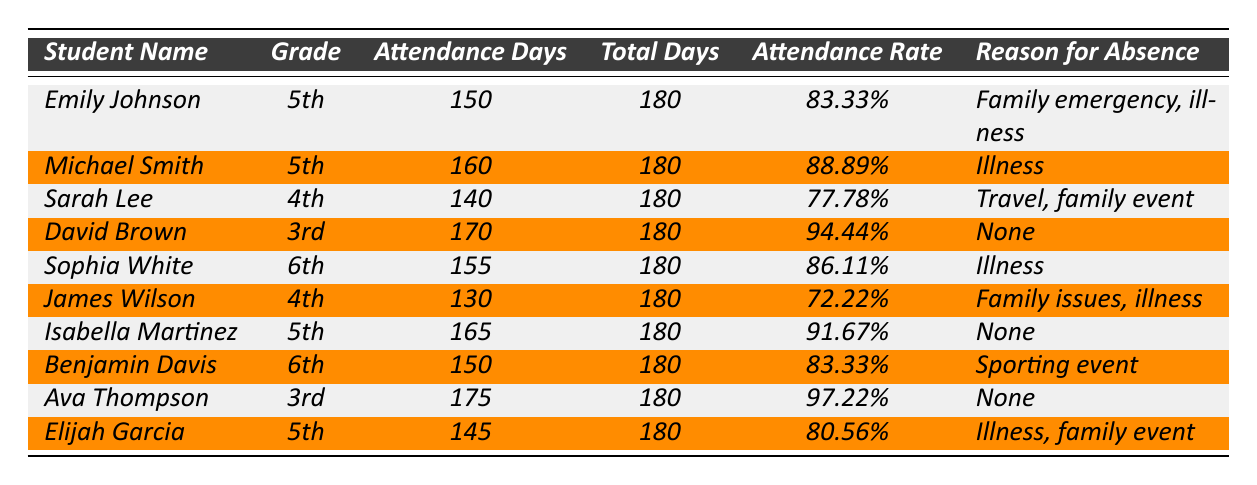What is the attendance rate of Ava Thompson? By looking at the row for Ava Thompson in the table, her attendance rate is listed as 97.22%.
Answer: 97.22% How many attendance days did David Brown have? The table shows that David Brown has 170 attendance days.
Answer: 170 Which student had the lowest attendance rate? By comparing the attendance rates in the table, James Wilson has the lowest rate at 72.22%.
Answer: James Wilson How many students had perfect attendance days (i.e., 180 days)? Since none of the students reached 180 attendance days, the count is 0.
Answer: 0 What is the average attendance rate for students in 5th grade? The attendance rates for the 5th-grade students are 83.33%, 88.89%, 91.67%, and 80.56%. Summing these gives 344.45% and dividing by 4 gives an average of 86.11%.
Answer: 86.11% Which student missed the most days, and what was the reason? Sarah Lee missed 40 days (180 - 140), and her reasons were travel and a family event.
Answer: Sarah Lee; travel, family event What is the total attendance across all students? Adding the attendance days: 150 + 160 + 140 + 170 + 155 + 130 + 165 + 150 + 175 + 145 = 1,565 days.
Answer: 1,565 days Are there any students who had no reported reasons for absence? Yes, David Brown and Isabella Martinez reported no reasons for absence.
Answer: Yes What percentage of students had an attendance rate above 85%? Four students (Michael Smith, Isabella Martinez, David Brown, and Ava Thompson) had an attendance rate above 85%. Since there are 10 students total, the percentage is (4/10)*100 = 40%.
Answer: 40% Which student had the highest attendance days, and what was their attendance rate? Ava Thompson had the highest attendance days at 175, with an attendance rate of 97.22%.
Answer: Ava Thompson; 97.22% 